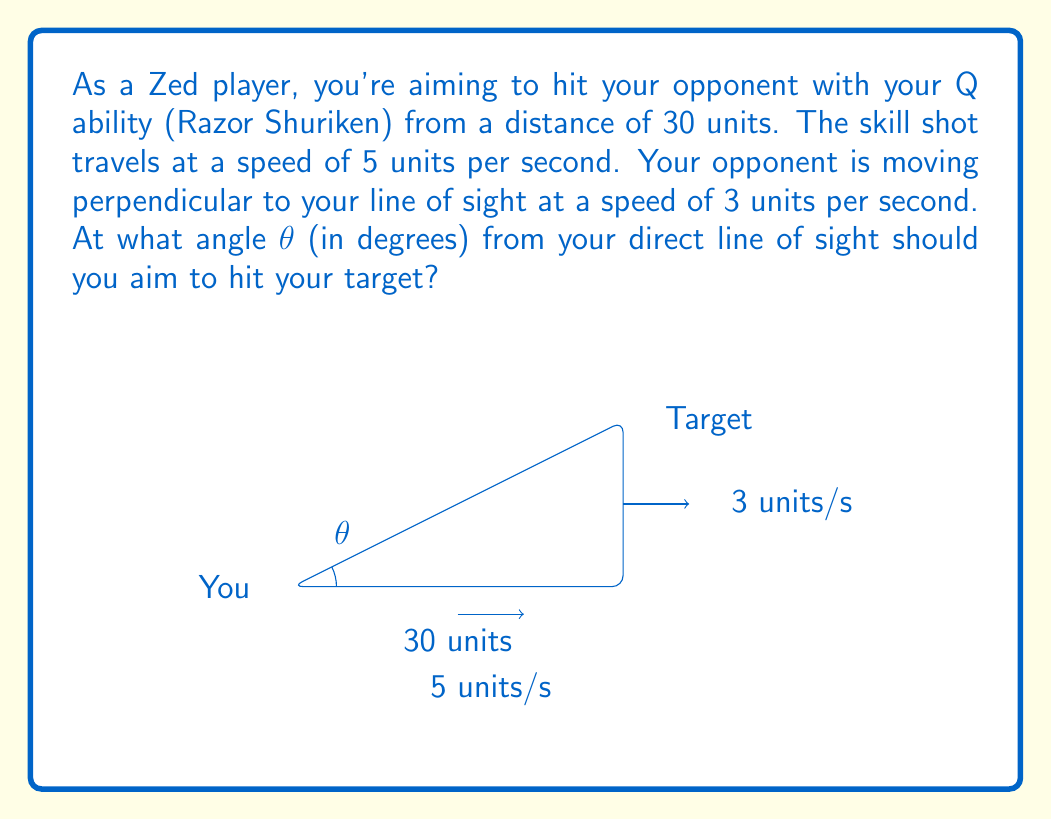What is the answer to this math problem? Let's approach this step-by-step:

1) First, we need to determine the time it takes for the skill shot to reach the target's initial position:
   $t = \frac{\text{distance}}{\text{speed}} = \frac{30}{5} = 6$ seconds

2) During this time, the target will have moved perpendicular to your line of sight:
   Distance moved by target = $3 \text{ units/s} \times 6 \text{ s} = 18$ units

3) Now we have a right triangle:
   - The base is 30 units (original distance)
   - The height is 18 units (distance moved by target)

4) We can find the angle θ using the arctangent function:
   $$\theta = \arctan(\frac{\text{opposite}}{\text{adjacent}}) = \arctan(\frac{18}{30})$$

5) Simplify the fraction:
   $$\theta = \arctan(\frac{3}{5})$$

6) Calculate the angle:
   $$\theta \approx 30.96^\circ$$

Therefore, you should aim approximately 30.96° above your direct line of sight to hit the moving target.
Answer: $30.96^\circ$ 